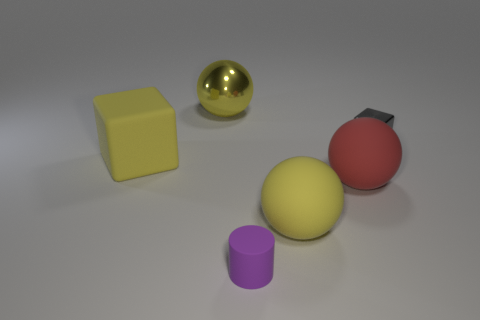Subtract all large yellow metallic spheres. How many spheres are left? 2 Subtract all gray cylinders. How many yellow spheres are left? 2 Add 3 large red rubber balls. How many objects exist? 9 Subtract all cylinders. How many objects are left? 5 Subtract all small purple matte cylinders. Subtract all yellow blocks. How many objects are left? 4 Add 3 large objects. How many large objects are left? 7 Add 2 shiny balls. How many shiny balls exist? 3 Subtract 0 purple blocks. How many objects are left? 6 